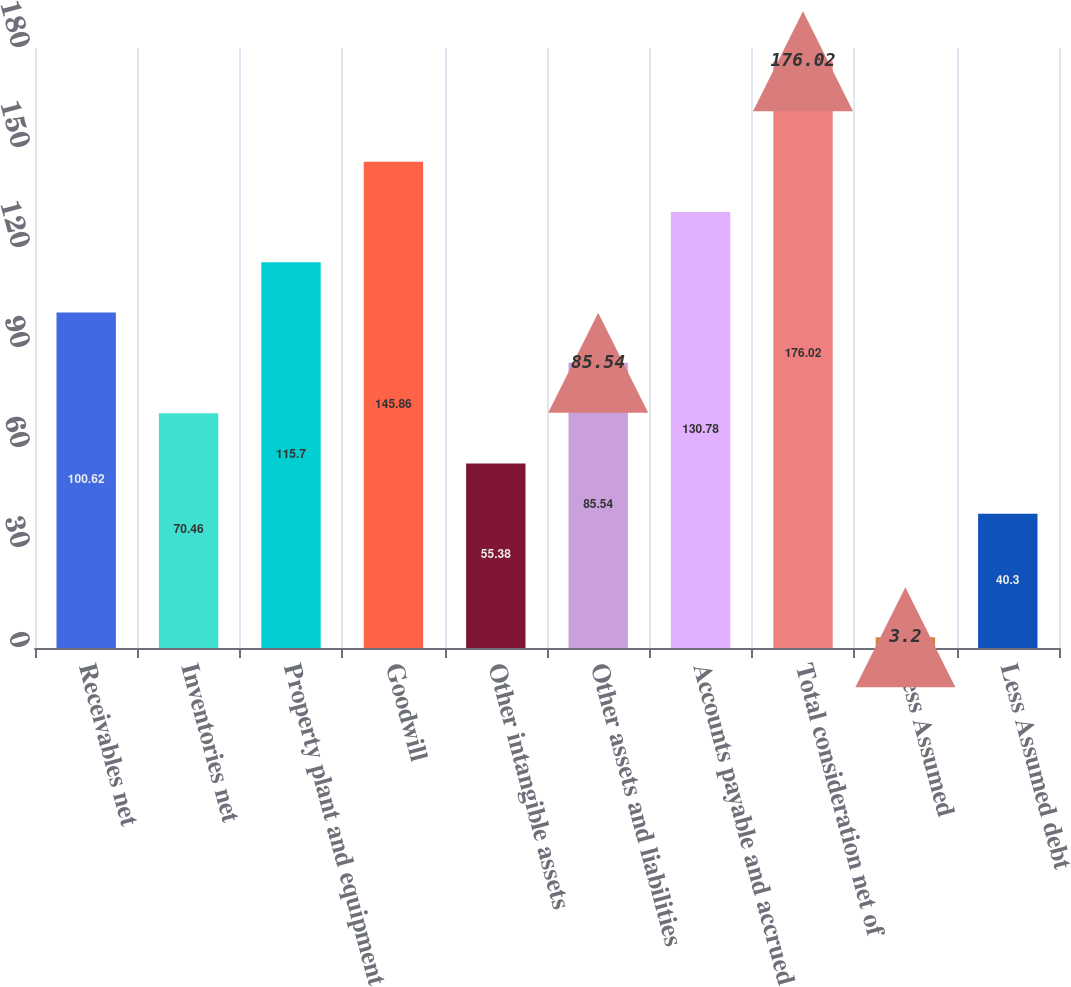<chart> <loc_0><loc_0><loc_500><loc_500><bar_chart><fcel>Receivables net<fcel>Inventories net<fcel>Property plant and equipment<fcel>Goodwill<fcel>Other intangible assets<fcel>Other assets and liabilities<fcel>Accounts payable and accrued<fcel>Total consideration net of<fcel>Less Assumed<fcel>Less Assumed debt<nl><fcel>100.62<fcel>70.46<fcel>115.7<fcel>145.86<fcel>55.38<fcel>85.54<fcel>130.78<fcel>176.02<fcel>3.2<fcel>40.3<nl></chart> 